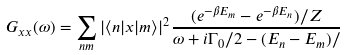<formula> <loc_0><loc_0><loc_500><loc_500>G _ { x x } ( \omega ) = \sum _ { n m } | \langle n | x | m \rangle | ^ { 2 } \frac { ( e ^ { - \beta E _ { m } } - e ^ { - \beta E _ { n } } ) / Z } { \omega + i \Gamma _ { 0 } / 2 - ( E _ { n } - E _ { m } ) / }</formula> 